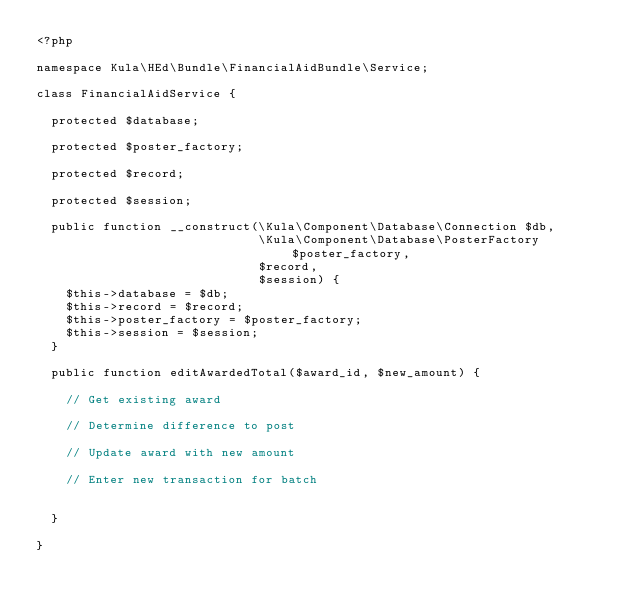Convert code to text. <code><loc_0><loc_0><loc_500><loc_500><_PHP_><?php

namespace Kula\HEd\Bundle\FinancialAidBundle\Service;

class FinancialAidService {
  
  protected $database;
  
  protected $poster_factory;
  
  protected $record;
  
  protected $session;
  
  public function __construct(\Kula\Component\Database\Connection $db, 
                              \Kula\Component\Database\PosterFactory $poster_factory,
                              $record, 
                              $session) {
    $this->database = $db;
    $this->record = $record;
    $this->poster_factory = $poster_factory;
    $this->session = $session;
  }
  
  public function editAwardedTotal($award_id, $new_amount) {
    
    // Get existing award
    
    // Determine difference to post
    
    // Update award with new amount
    
    // Enter new transaction for batch
    
    
  }
  
}</code> 